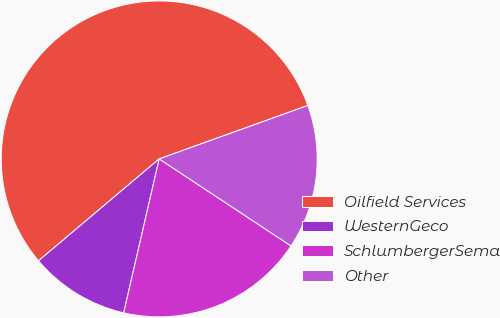Convert chart. <chart><loc_0><loc_0><loc_500><loc_500><pie_chart><fcel>Oilfield Services<fcel>WesternGeco<fcel>SchlumbergerSema<fcel>Other<nl><fcel>55.67%<fcel>10.23%<fcel>19.32%<fcel>14.78%<nl></chart> 